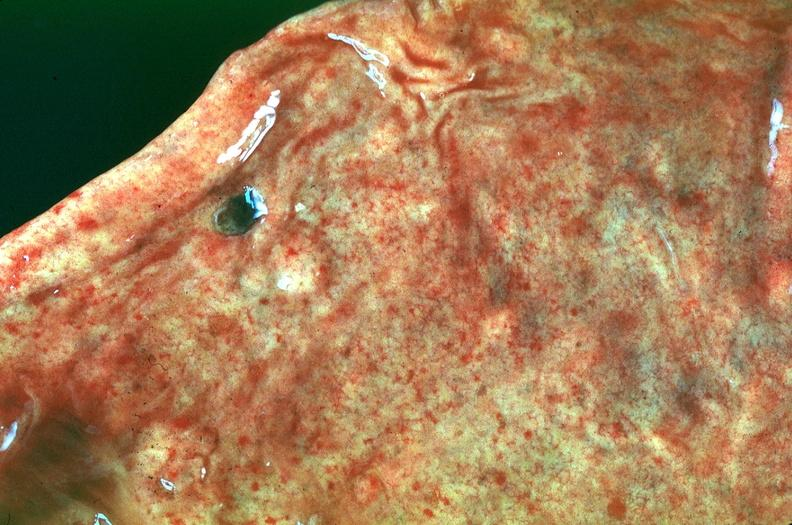s angiogram saphenous vein bypass graft present?
Answer the question using a single word or phrase. No 